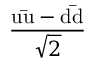Convert formula to latex. <formula><loc_0><loc_0><loc_500><loc_500>\frac { u { \bar { u } } - d { \bar { d } } } { \sqrt { 2 } }</formula> 